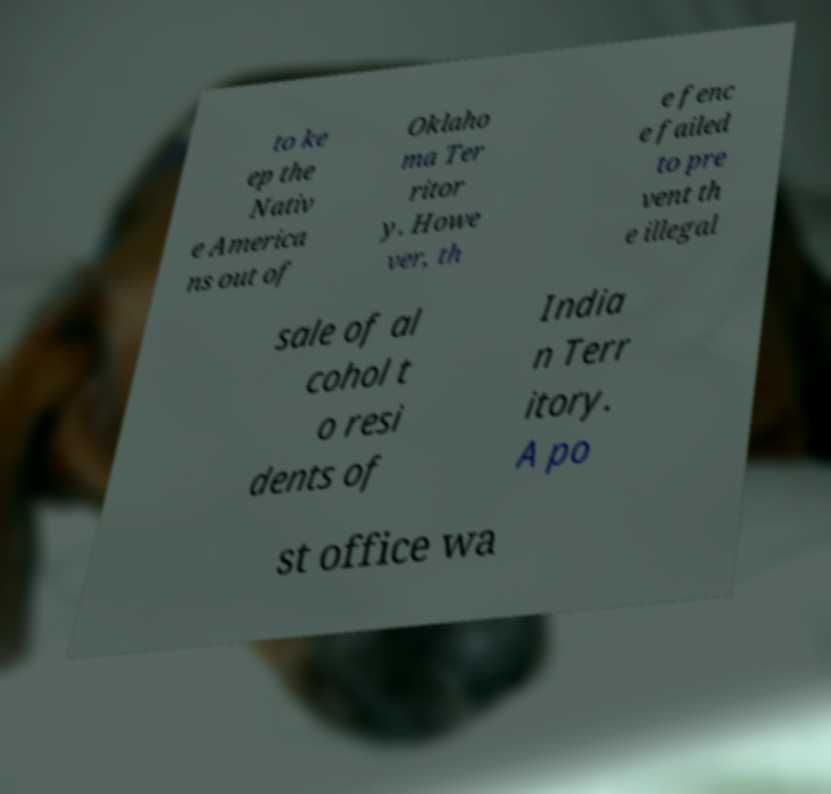Can you accurately transcribe the text from the provided image for me? to ke ep the Nativ e America ns out of Oklaho ma Ter ritor y. Howe ver, th e fenc e failed to pre vent th e illegal sale of al cohol t o resi dents of India n Terr itory. A po st office wa 